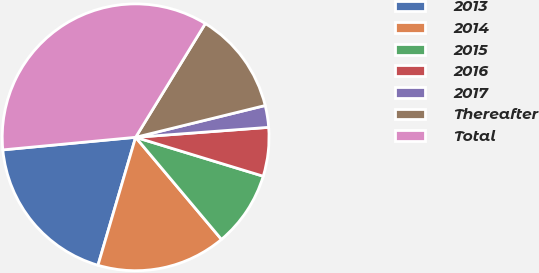Convert chart. <chart><loc_0><loc_0><loc_500><loc_500><pie_chart><fcel>2013<fcel>2014<fcel>2015<fcel>2016<fcel>2017<fcel>Thereafter<fcel>Total<nl><fcel>18.94%<fcel>15.68%<fcel>9.16%<fcel>5.9%<fcel>2.64%<fcel>12.42%<fcel>35.25%<nl></chart> 